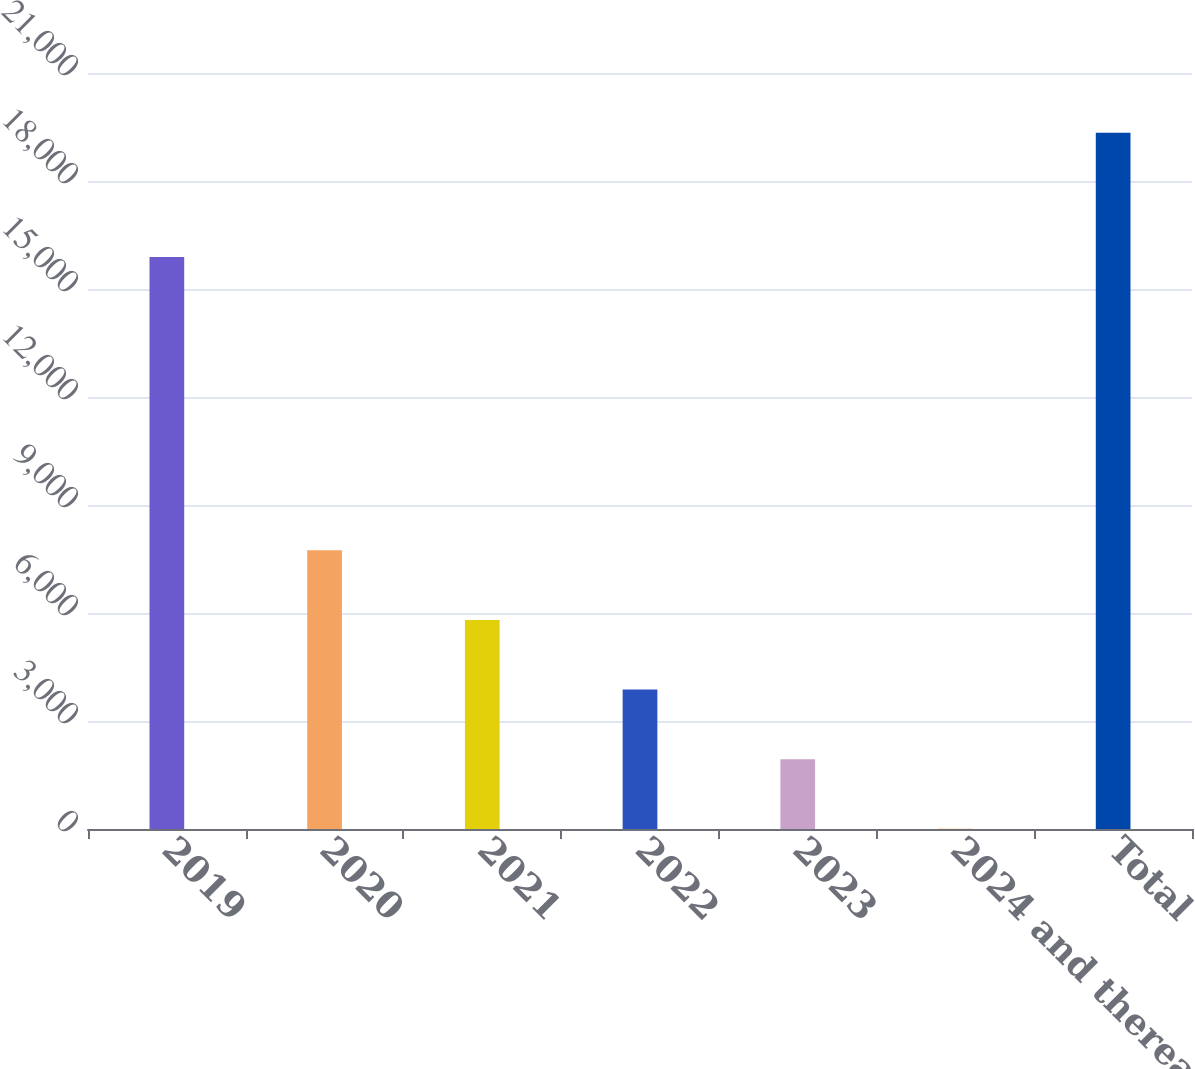Convert chart to OTSL. <chart><loc_0><loc_0><loc_500><loc_500><bar_chart><fcel>2019<fcel>2020<fcel>2021<fcel>2022<fcel>2023<fcel>2024 and thereafter<fcel>Total<nl><fcel>15889<fcel>7739.8<fcel>5806.1<fcel>3872.4<fcel>1938.7<fcel>5<fcel>19342<nl></chart> 